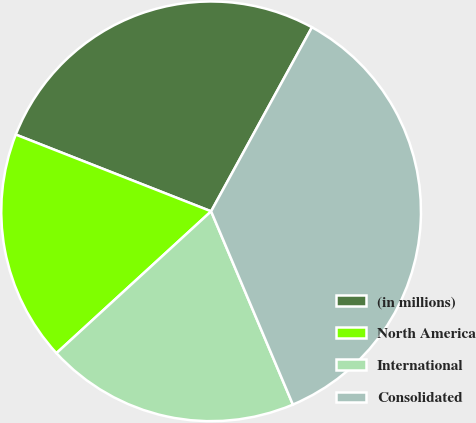<chart> <loc_0><loc_0><loc_500><loc_500><pie_chart><fcel>(in millions)<fcel>North America<fcel>International<fcel>Consolidated<nl><fcel>27.02%<fcel>17.77%<fcel>19.56%<fcel>35.65%<nl></chart> 